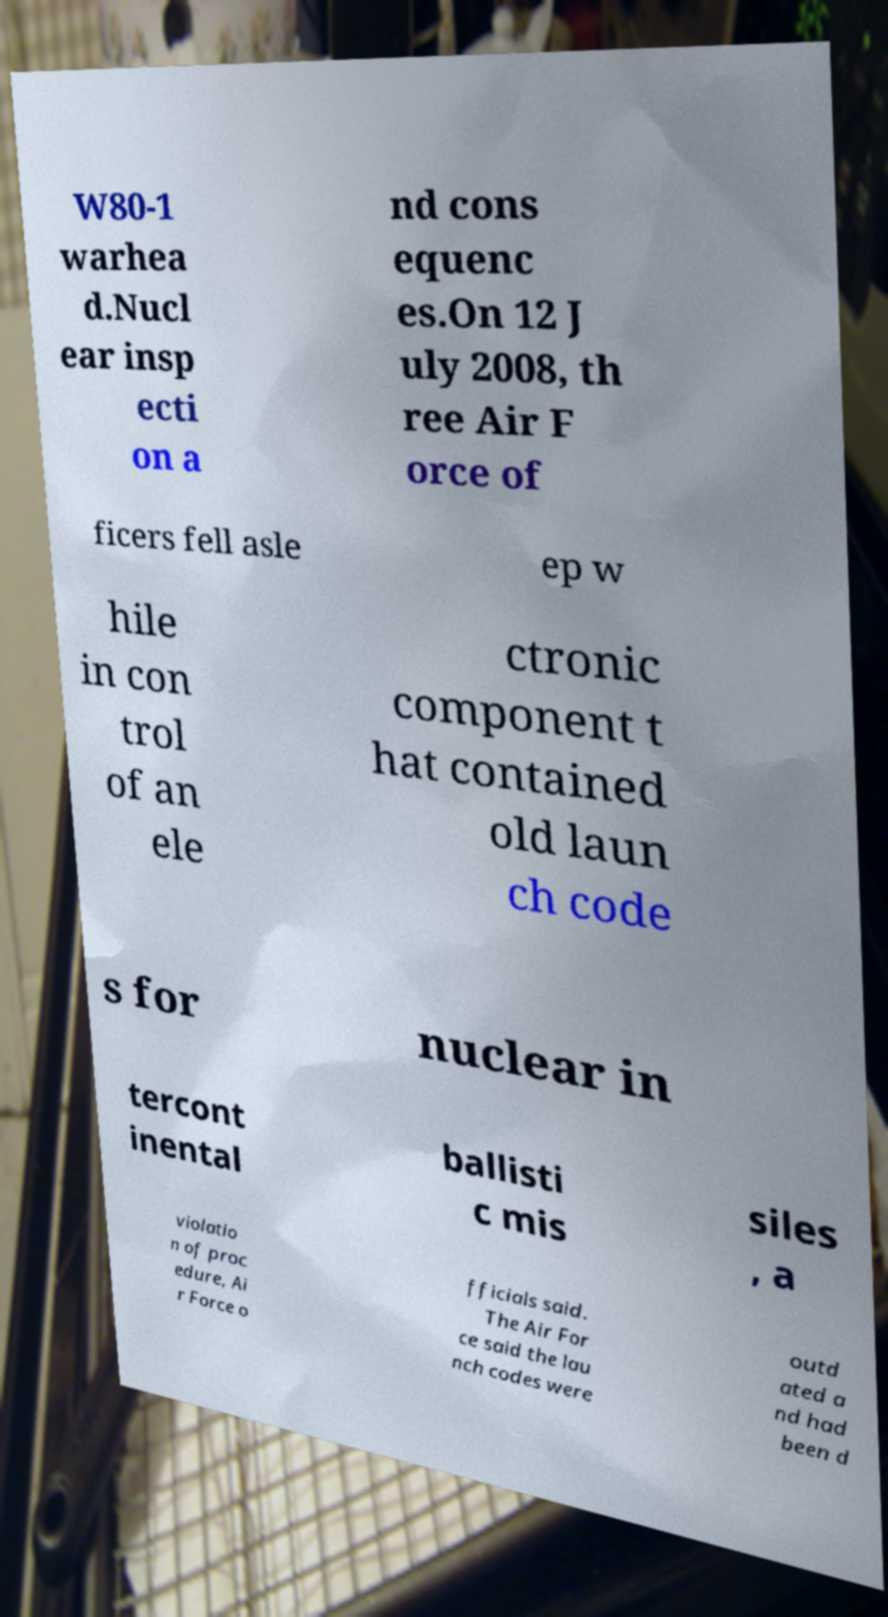Please read and relay the text visible in this image. What does it say? W80-1 warhea d.Nucl ear insp ecti on a nd cons equenc es.On 12 J uly 2008, th ree Air F orce of ficers fell asle ep w hile in con trol of an ele ctronic component t hat contained old laun ch code s for nuclear in tercont inental ballisti c mis siles , a violatio n of proc edure, Ai r Force o fficials said. The Air For ce said the lau nch codes were outd ated a nd had been d 